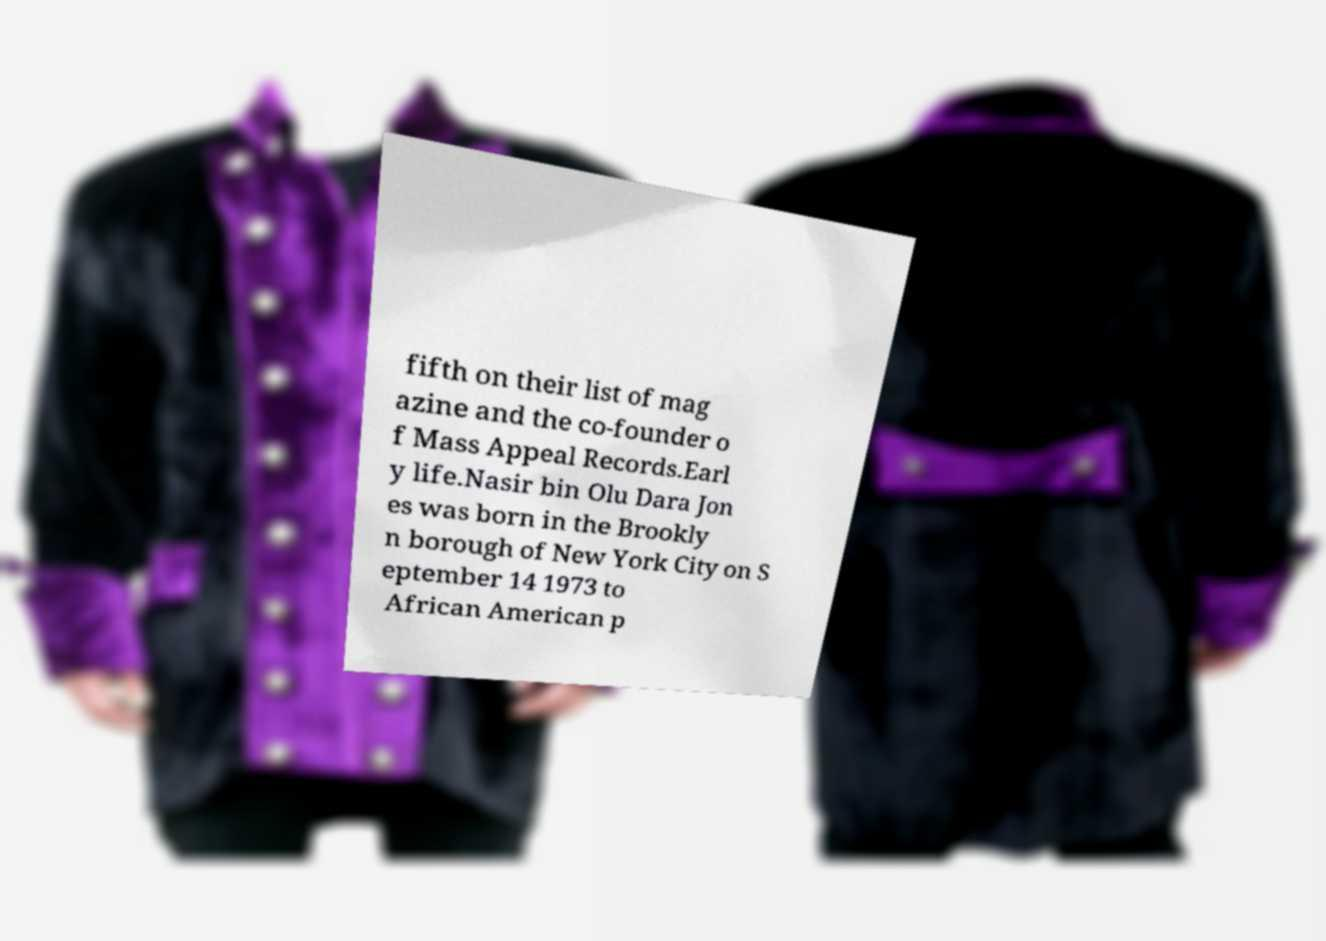For documentation purposes, I need the text within this image transcribed. Could you provide that? fifth on their list of mag azine and the co-founder o f Mass Appeal Records.Earl y life.Nasir bin Olu Dara Jon es was born in the Brookly n borough of New York City on S eptember 14 1973 to African American p 